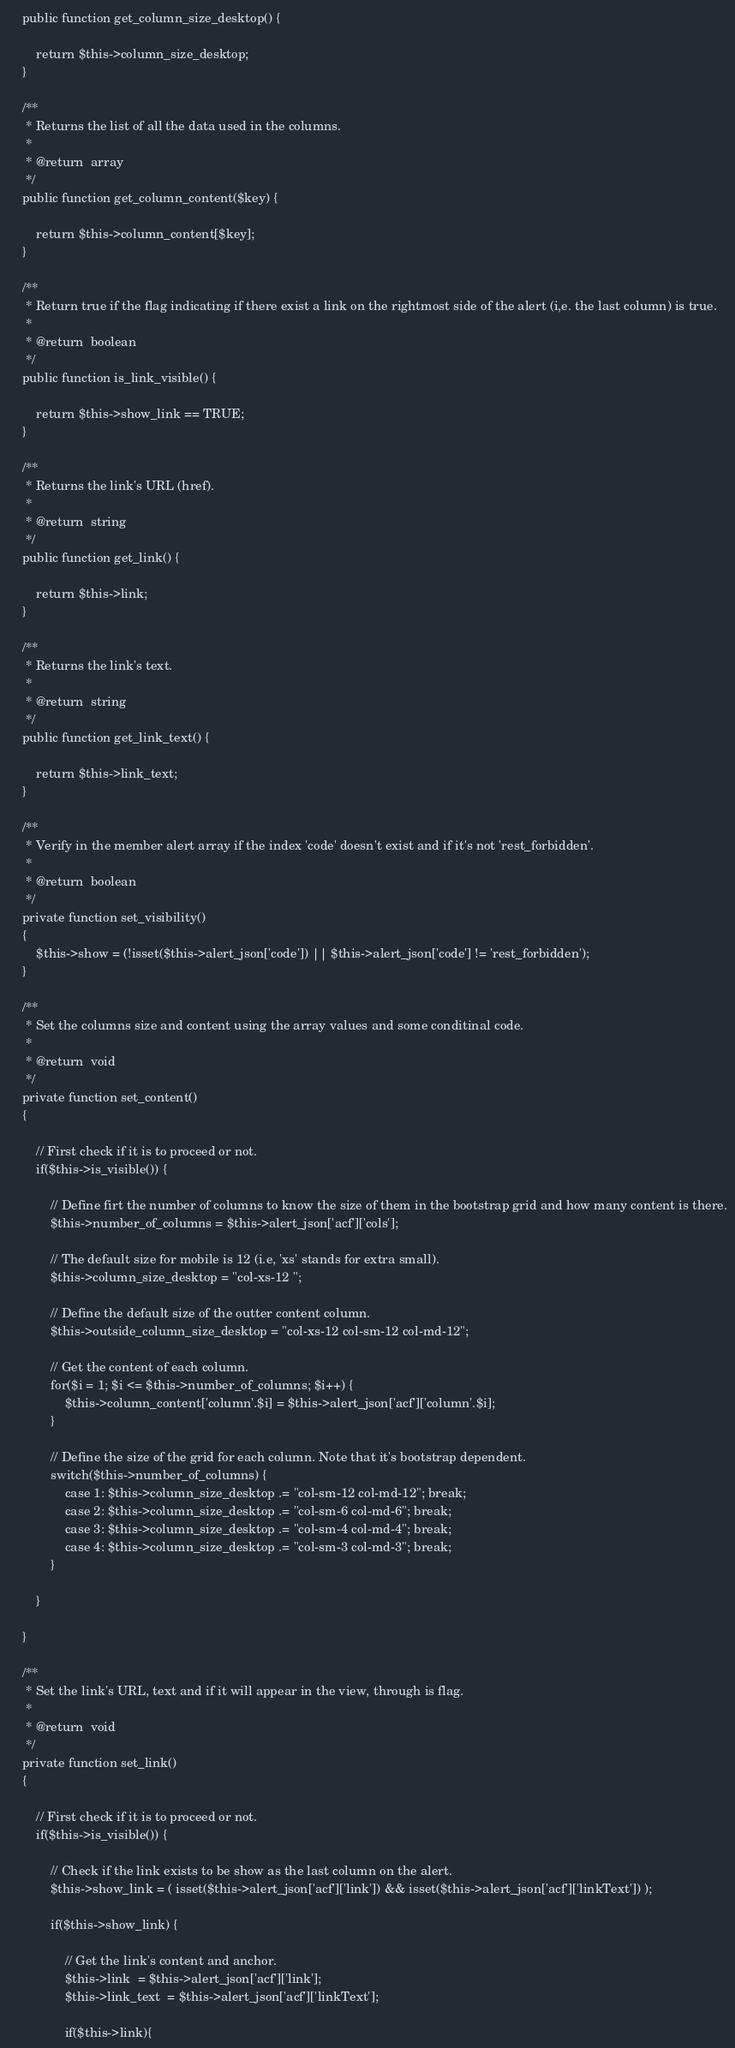<code> <loc_0><loc_0><loc_500><loc_500><_PHP_>	public function get_column_size_desktop() {

		return $this->column_size_desktop;
	}

	/**
	 * Returns the list of all the data used in the columns.
	 *
	 * @return	array
	 */
	public function get_column_content($key) {

		return $this->column_content[$key];
	}

	/**
	 * Return true if the flag indicating if there exist a link on the rightmost side of the alert (i,e. the last column) is true.
	 *
	 * @return	boolean
	 */
	public function is_link_visible() {

		return $this->show_link == TRUE;
	}

	/**
	 * Returns the link's URL (href).
	 *
	 * @return	string
	 */
	public function get_link() {

		return $this->link;
	}

	/**
	 * Returns the link's text.
	 *
	 * @return	string
	 */
	public function get_link_text() {

		return $this->link_text;
	}

    /**
	 * Verify in the member alert array if the index 'code' doesn't exist and if it's not 'rest_forbidden'.
	 *
	 * @return	boolean
	 */
    private function set_visibility()
    {
        $this->show = (!isset($this->alert_json['code']) || $this->alert_json['code'] != 'rest_forbidden');
    }

    /**
	 * Set the columns size and content using the array values and some conditinal code.
	 *
	 * @return	void
	 */
    private function set_content()
    {

        // First check if it is to proceed or not.
        if($this->is_visible()) {

            // Define firt the number of columns to know the size of them in the bootstrap grid and how many content is there.
			$this->number_of_columns = $this->alert_json['acf']['cols'];

			// The default size for mobile is 12 (i.e, 'xs' stands for extra small).
			$this->column_size_desktop = "col-xs-12 ";

			// Define the default size of the outter content column.
			$this->outside_column_size_desktop = "col-xs-12 col-sm-12 col-md-12";

			// Get the content of each column.
			for($i = 1; $i <= $this->number_of_columns; $i++) {
				$this->column_content['column'.$i] = $this->alert_json['acf']['column'.$i];
			}

			// Define the size of the grid for each column. Note that it's bootstrap dependent.
			switch($this->number_of_columns) {
				case 1: $this->column_size_desktop .= "col-sm-12 col-md-12"; break;
				case 2: $this->column_size_desktop .= "col-sm-6 col-md-6"; break;
				case 3: $this->column_size_desktop .= "col-sm-4 col-md-4"; break;
				case 4: $this->column_size_desktop .= "col-sm-3 col-md-3"; break;
			}

        }

    }

    /**
	 * Set the link's URL, text and if it will appear in the view, through is flag.
	 *
	 * @return	void
	 */
    private function set_link()
    {

        // First check if it is to proceed or not.
        if($this->is_visible()) {

            // Check if the link exists to be show as the last column on the alert.
            $this->show_link = ( isset($this->alert_json['acf']['link']) && isset($this->alert_json['acf']['linkText']) );
            
            if($this->show_link) {

                // Get the link's content and anchor.
				$this->link  = $this->alert_json['acf']['link'];
				$this->link_text  = $this->alert_json['acf']['linkText'];
				
				if($this->link){</code> 